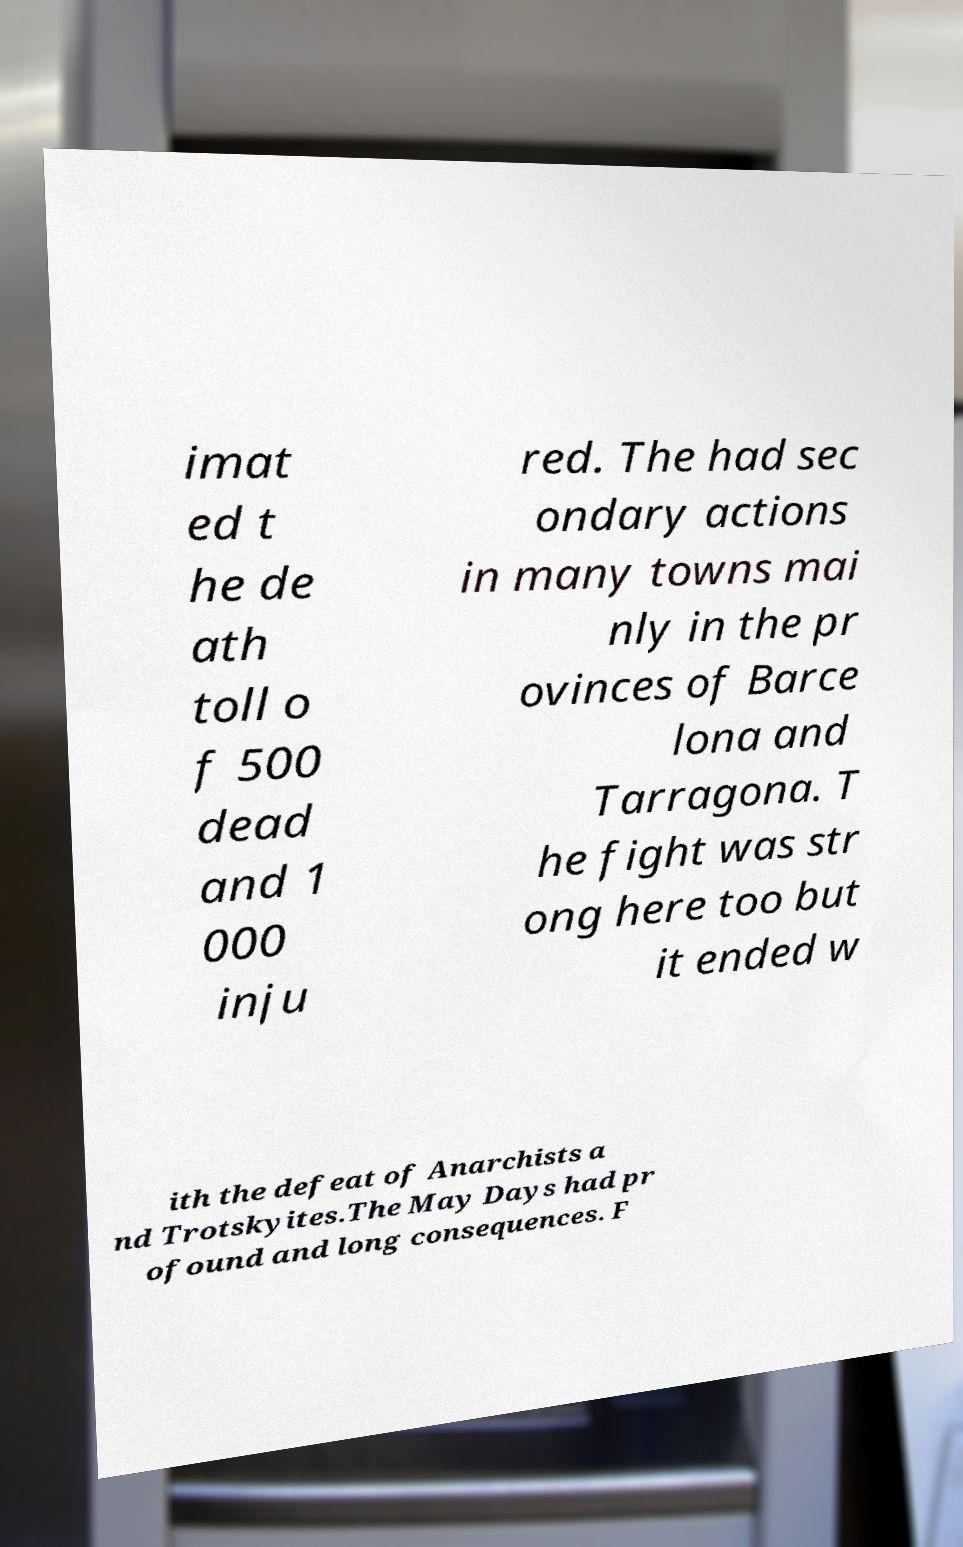I need the written content from this picture converted into text. Can you do that? imat ed t he de ath toll o f 500 dead and 1 000 inju red. The had sec ondary actions in many towns mai nly in the pr ovinces of Barce lona and Tarragona. T he fight was str ong here too but it ended w ith the defeat of Anarchists a nd Trotskyites.The May Days had pr ofound and long consequences. F 